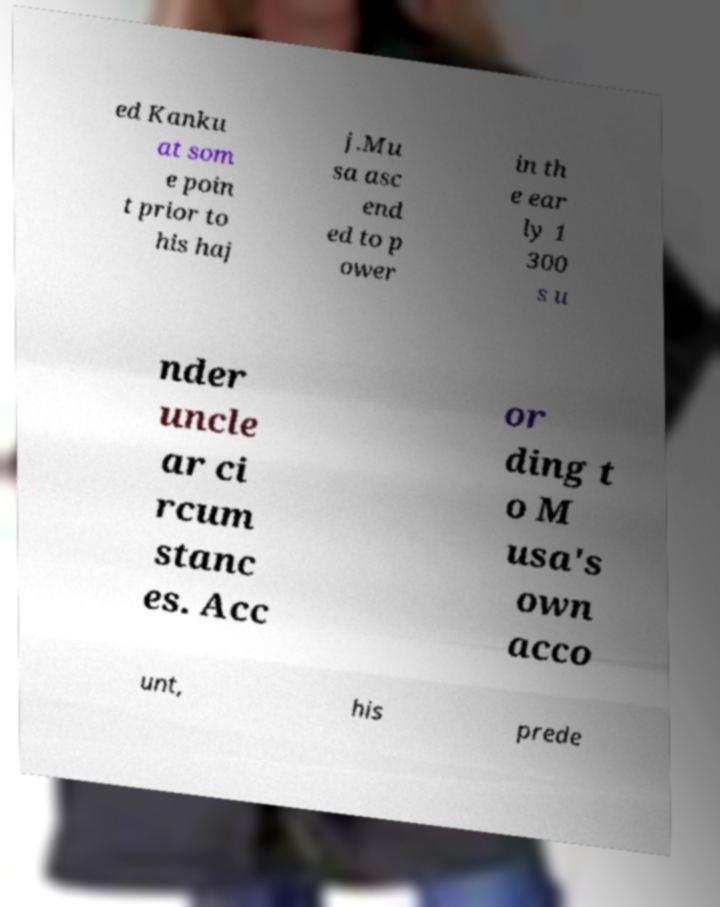Could you extract and type out the text from this image? ed Kanku at som e poin t prior to his haj j.Mu sa asc end ed to p ower in th e ear ly 1 300 s u nder uncle ar ci rcum stanc es. Acc or ding t o M usa's own acco unt, his prede 